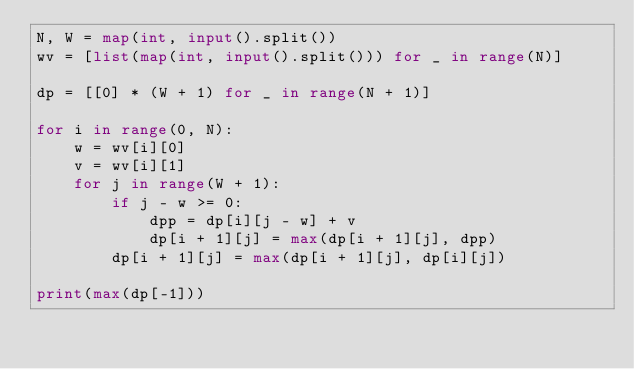<code> <loc_0><loc_0><loc_500><loc_500><_Python_>N, W = map(int, input().split())
wv = [list(map(int, input().split())) for _ in range(N)]

dp = [[0] * (W + 1) for _ in range(N + 1)]

for i in range(0, N):
    w = wv[i][0]
    v = wv[i][1]
    for j in range(W + 1):
        if j - w >= 0:
            dpp = dp[i][j - w] + v
            dp[i + 1][j] = max(dp[i + 1][j], dpp)    
        dp[i + 1][j] = max(dp[i + 1][j], dp[i][j])

print(max(dp[-1]))</code> 